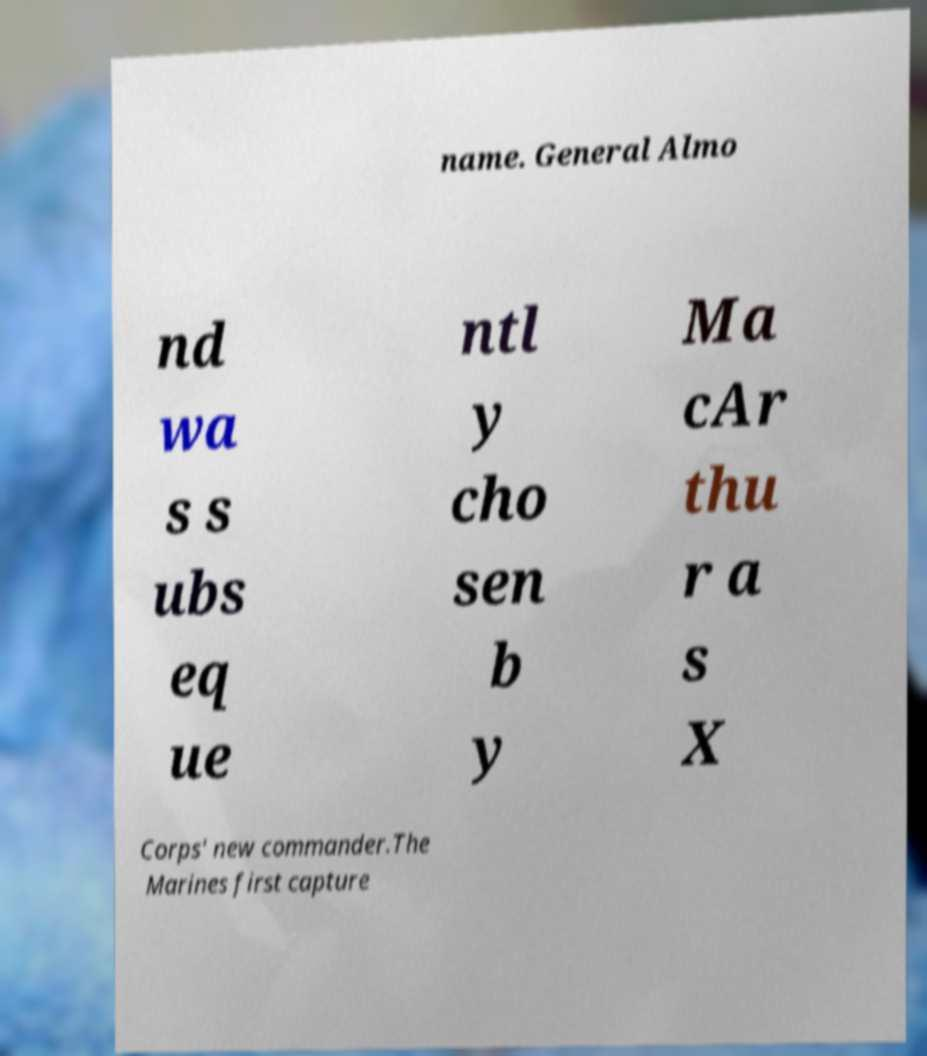What messages or text are displayed in this image? I need them in a readable, typed format. name. General Almo nd wa s s ubs eq ue ntl y cho sen b y Ma cAr thu r a s X Corps' new commander.The Marines first capture 